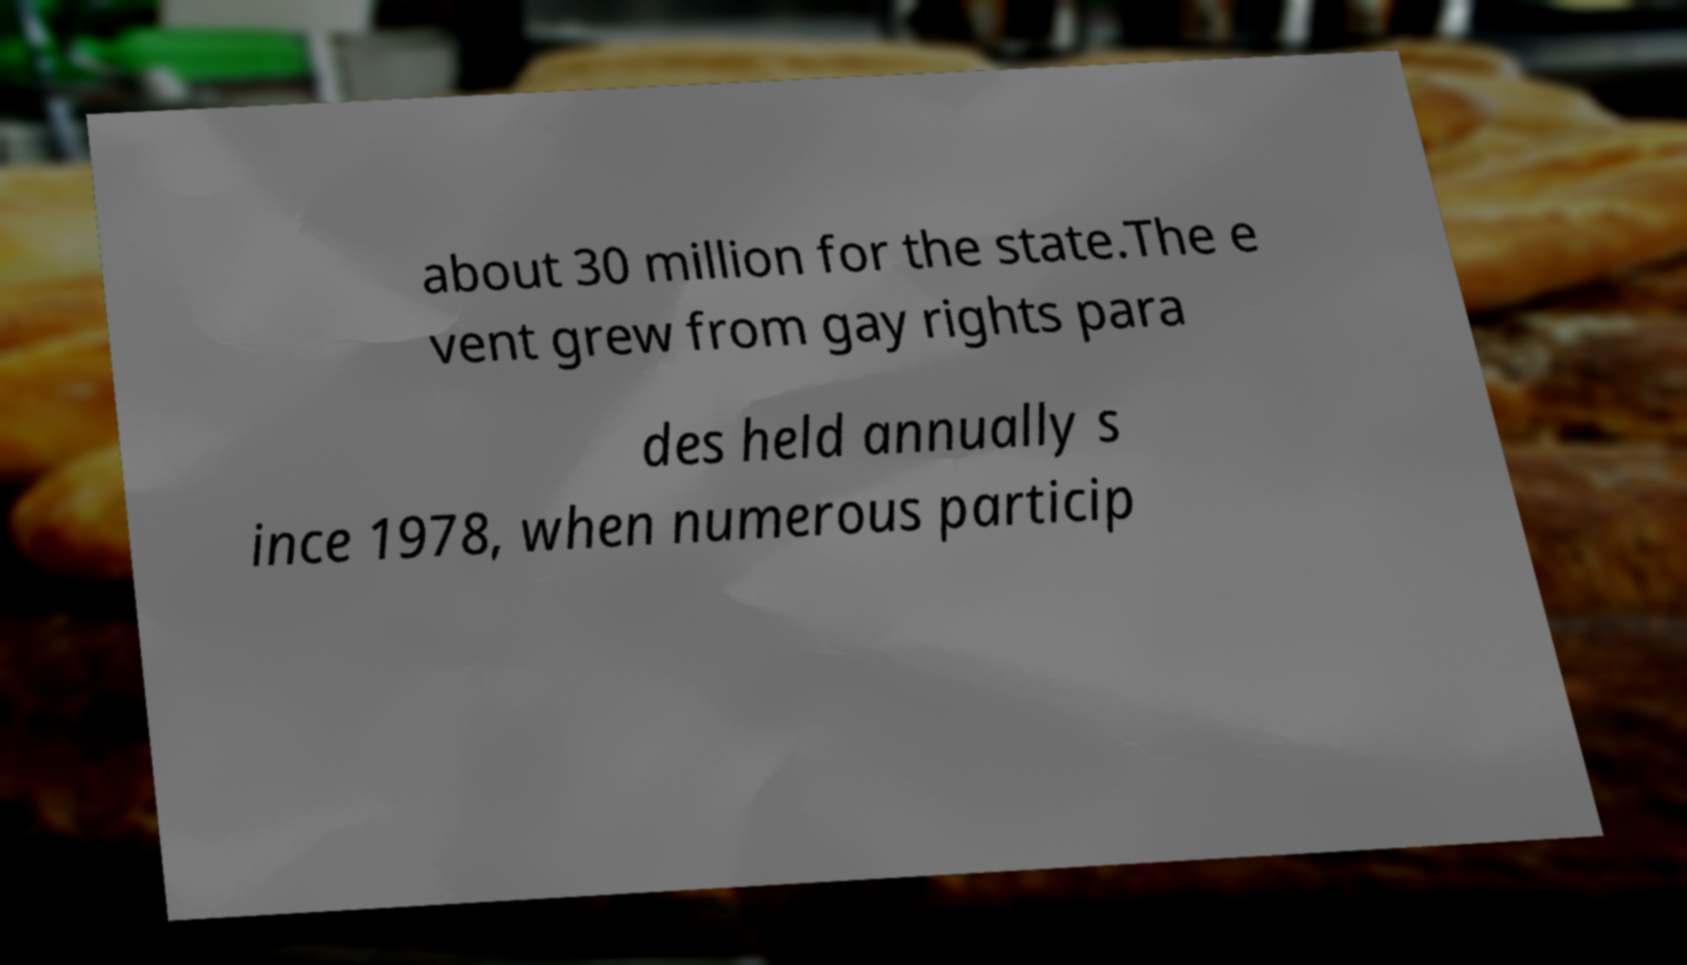There's text embedded in this image that I need extracted. Can you transcribe it verbatim? about 30 million for the state.The e vent grew from gay rights para des held annually s ince 1978, when numerous particip 